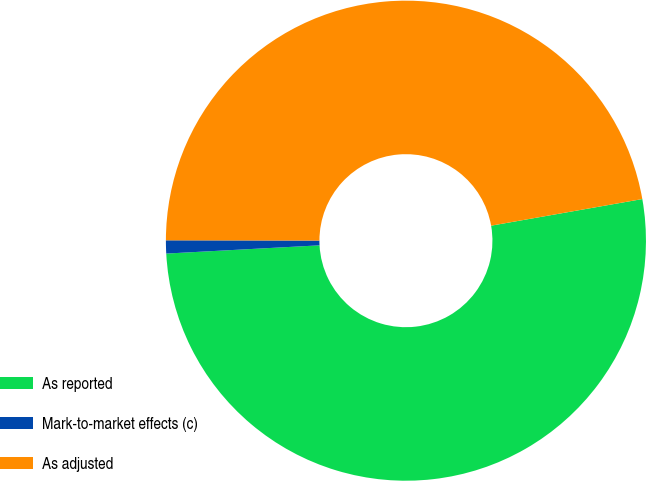Convert chart. <chart><loc_0><loc_0><loc_500><loc_500><pie_chart><fcel>As reported<fcel>Mark-to-market effects (c)<fcel>As adjusted<nl><fcel>51.92%<fcel>0.88%<fcel>47.2%<nl></chart> 